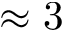Convert formula to latex. <formula><loc_0><loc_0><loc_500><loc_500>\approx 3</formula> 